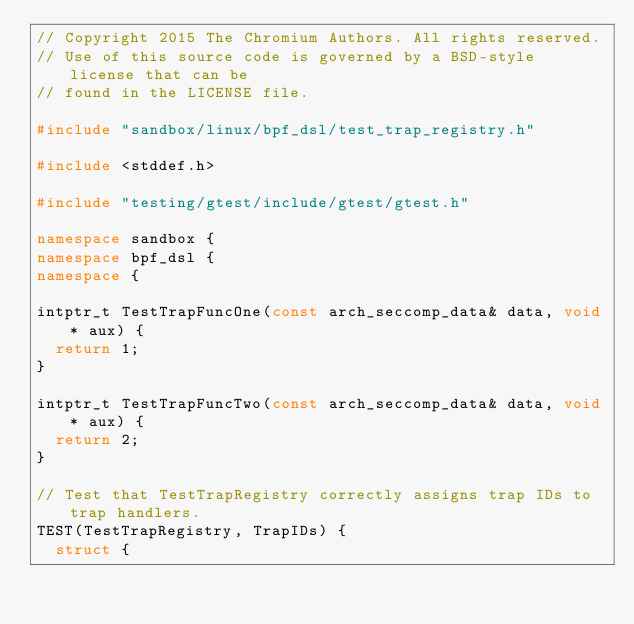<code> <loc_0><loc_0><loc_500><loc_500><_C++_>// Copyright 2015 The Chromium Authors. All rights reserved.
// Use of this source code is governed by a BSD-style license that can be
// found in the LICENSE file.

#include "sandbox/linux/bpf_dsl/test_trap_registry.h"

#include <stddef.h>

#include "testing/gtest/include/gtest/gtest.h"

namespace sandbox {
namespace bpf_dsl {
namespace {

intptr_t TestTrapFuncOne(const arch_seccomp_data& data, void* aux) {
  return 1;
}

intptr_t TestTrapFuncTwo(const arch_seccomp_data& data, void* aux) {
  return 2;
}

// Test that TestTrapRegistry correctly assigns trap IDs to trap handlers.
TEST(TestTrapRegistry, TrapIDs) {
  struct {</code> 